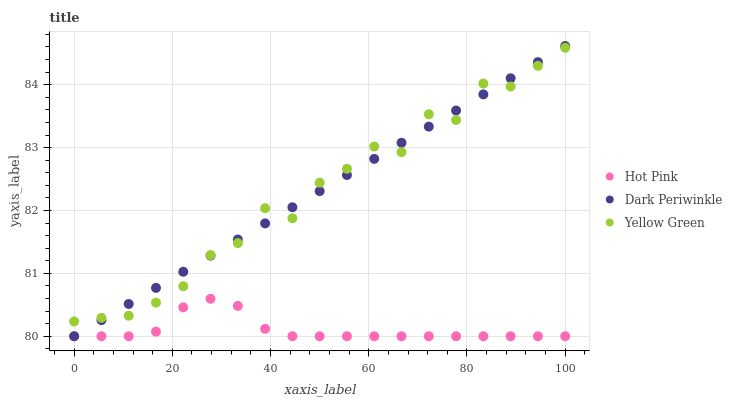Does Hot Pink have the minimum area under the curve?
Answer yes or no. Yes. Does Dark Periwinkle have the maximum area under the curve?
Answer yes or no. Yes. Does Yellow Green have the minimum area under the curve?
Answer yes or no. No. Does Yellow Green have the maximum area under the curve?
Answer yes or no. No. Is Dark Periwinkle the smoothest?
Answer yes or no. Yes. Is Yellow Green the roughest?
Answer yes or no. Yes. Is Yellow Green the smoothest?
Answer yes or no. No. Is Dark Periwinkle the roughest?
Answer yes or no. No. Does Hot Pink have the lowest value?
Answer yes or no. Yes. Does Yellow Green have the lowest value?
Answer yes or no. No. Does Dark Periwinkle have the highest value?
Answer yes or no. Yes. Does Yellow Green have the highest value?
Answer yes or no. No. Is Hot Pink less than Yellow Green?
Answer yes or no. Yes. Is Yellow Green greater than Hot Pink?
Answer yes or no. Yes. Does Hot Pink intersect Dark Periwinkle?
Answer yes or no. Yes. Is Hot Pink less than Dark Periwinkle?
Answer yes or no. No. Is Hot Pink greater than Dark Periwinkle?
Answer yes or no. No. Does Hot Pink intersect Yellow Green?
Answer yes or no. No. 